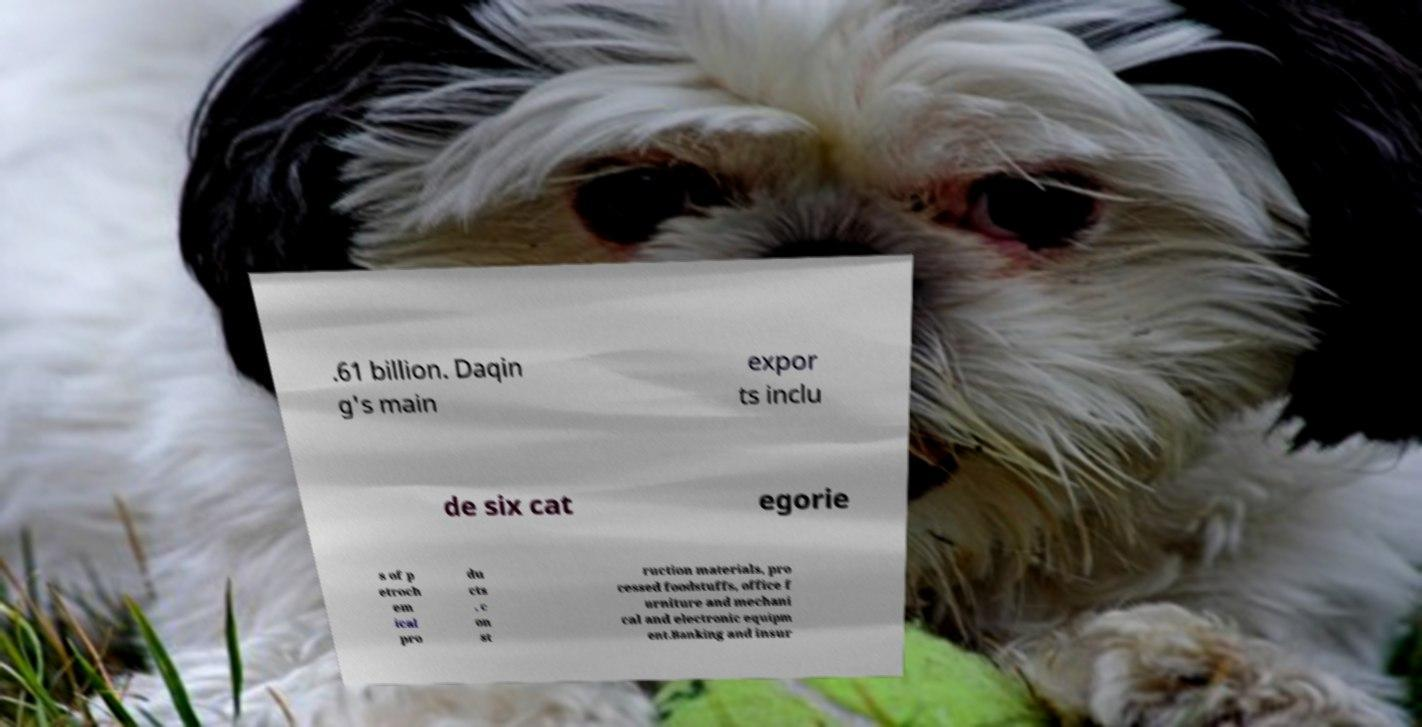Can you accurately transcribe the text from the provided image for me? .61 billion. Daqin g's main expor ts inclu de six cat egorie s of p etroch em ical pro du cts , c on st ruction materials, pro cessed foodstuffs, office f urniture and mechani cal and electronic equipm ent.Banking and insur 